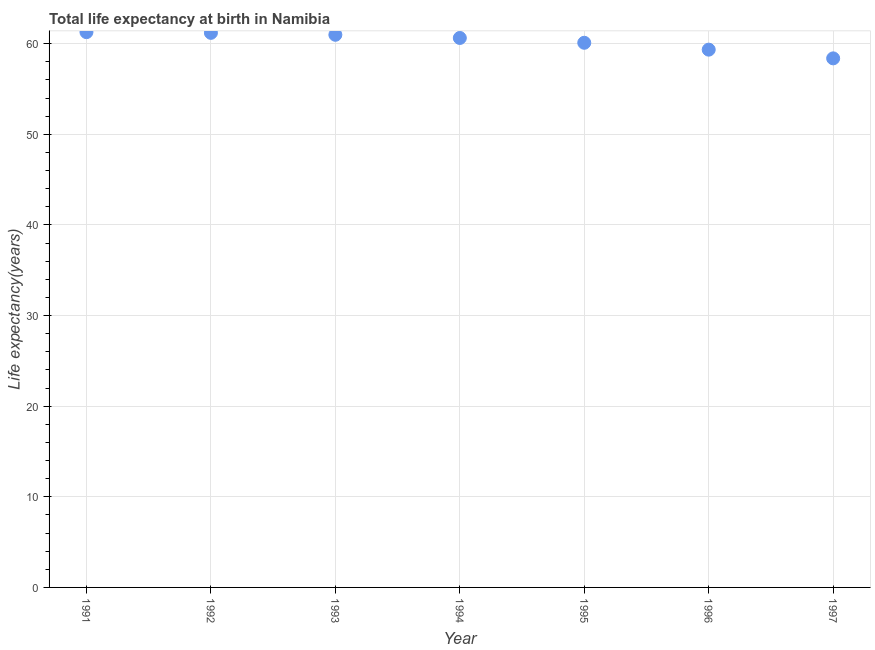What is the life expectancy at birth in 1995?
Your answer should be very brief. 60.09. Across all years, what is the maximum life expectancy at birth?
Ensure brevity in your answer.  61.27. Across all years, what is the minimum life expectancy at birth?
Make the answer very short. 58.37. What is the sum of the life expectancy at birth?
Keep it short and to the point. 421.87. What is the difference between the life expectancy at birth in 1994 and 1996?
Ensure brevity in your answer.  1.29. What is the average life expectancy at birth per year?
Your response must be concise. 60.27. What is the median life expectancy at birth?
Your answer should be very brief. 60.63. In how many years, is the life expectancy at birth greater than 18 years?
Your answer should be very brief. 7. What is the ratio of the life expectancy at birth in 1993 to that in 1996?
Offer a very short reply. 1.03. Is the difference between the life expectancy at birth in 1992 and 1997 greater than the difference between any two years?
Your response must be concise. No. What is the difference between the highest and the second highest life expectancy at birth?
Your answer should be very brief. 0.08. What is the difference between the highest and the lowest life expectancy at birth?
Keep it short and to the point. 2.89. Does the life expectancy at birth monotonically increase over the years?
Provide a short and direct response. No. How many years are there in the graph?
Keep it short and to the point. 7. What is the difference between two consecutive major ticks on the Y-axis?
Provide a short and direct response. 10. Does the graph contain any zero values?
Provide a succinct answer. No. What is the title of the graph?
Your response must be concise. Total life expectancy at birth in Namibia. What is the label or title of the X-axis?
Make the answer very short. Year. What is the label or title of the Y-axis?
Your response must be concise. Life expectancy(years). What is the Life expectancy(years) in 1991?
Provide a short and direct response. 61.27. What is the Life expectancy(years) in 1992?
Ensure brevity in your answer.  61.19. What is the Life expectancy(years) in 1993?
Make the answer very short. 60.98. What is the Life expectancy(years) in 1994?
Make the answer very short. 60.63. What is the Life expectancy(years) in 1995?
Give a very brief answer. 60.09. What is the Life expectancy(years) in 1996?
Your answer should be very brief. 59.34. What is the Life expectancy(years) in 1997?
Offer a very short reply. 58.37. What is the difference between the Life expectancy(years) in 1991 and 1992?
Provide a short and direct response. 0.08. What is the difference between the Life expectancy(years) in 1991 and 1993?
Provide a short and direct response. 0.29. What is the difference between the Life expectancy(years) in 1991 and 1994?
Offer a very short reply. 0.64. What is the difference between the Life expectancy(years) in 1991 and 1995?
Provide a short and direct response. 1.17. What is the difference between the Life expectancy(years) in 1991 and 1996?
Keep it short and to the point. 1.93. What is the difference between the Life expectancy(years) in 1991 and 1997?
Keep it short and to the point. 2.89. What is the difference between the Life expectancy(years) in 1992 and 1993?
Keep it short and to the point. 0.21. What is the difference between the Life expectancy(years) in 1992 and 1994?
Offer a very short reply. 0.56. What is the difference between the Life expectancy(years) in 1992 and 1995?
Offer a very short reply. 1.1. What is the difference between the Life expectancy(years) in 1992 and 1996?
Give a very brief answer. 1.85. What is the difference between the Life expectancy(years) in 1992 and 1997?
Provide a succinct answer. 2.82. What is the difference between the Life expectancy(years) in 1993 and 1994?
Your answer should be very brief. 0.35. What is the difference between the Life expectancy(years) in 1993 and 1995?
Offer a terse response. 0.88. What is the difference between the Life expectancy(years) in 1993 and 1996?
Your response must be concise. 1.64. What is the difference between the Life expectancy(years) in 1993 and 1997?
Make the answer very short. 2.6. What is the difference between the Life expectancy(years) in 1994 and 1995?
Make the answer very short. 0.53. What is the difference between the Life expectancy(years) in 1994 and 1996?
Give a very brief answer. 1.29. What is the difference between the Life expectancy(years) in 1994 and 1997?
Ensure brevity in your answer.  2.25. What is the difference between the Life expectancy(years) in 1995 and 1996?
Your answer should be very brief. 0.76. What is the difference between the Life expectancy(years) in 1995 and 1997?
Your answer should be very brief. 1.72. What is the difference between the Life expectancy(years) in 1996 and 1997?
Provide a succinct answer. 0.96. What is the ratio of the Life expectancy(years) in 1991 to that in 1992?
Offer a terse response. 1. What is the ratio of the Life expectancy(years) in 1991 to that in 1993?
Keep it short and to the point. 1. What is the ratio of the Life expectancy(years) in 1991 to that in 1995?
Provide a succinct answer. 1.02. What is the ratio of the Life expectancy(years) in 1991 to that in 1996?
Ensure brevity in your answer.  1.03. What is the ratio of the Life expectancy(years) in 1992 to that in 1993?
Offer a very short reply. 1. What is the ratio of the Life expectancy(years) in 1992 to that in 1996?
Provide a short and direct response. 1.03. What is the ratio of the Life expectancy(years) in 1992 to that in 1997?
Your answer should be compact. 1.05. What is the ratio of the Life expectancy(years) in 1993 to that in 1994?
Your answer should be very brief. 1.01. What is the ratio of the Life expectancy(years) in 1993 to that in 1995?
Make the answer very short. 1.01. What is the ratio of the Life expectancy(years) in 1993 to that in 1996?
Provide a succinct answer. 1.03. What is the ratio of the Life expectancy(years) in 1993 to that in 1997?
Provide a succinct answer. 1.04. What is the ratio of the Life expectancy(years) in 1994 to that in 1997?
Your answer should be compact. 1.04. What is the ratio of the Life expectancy(years) in 1995 to that in 1996?
Make the answer very short. 1.01. What is the ratio of the Life expectancy(years) in 1995 to that in 1997?
Your answer should be compact. 1.03. 